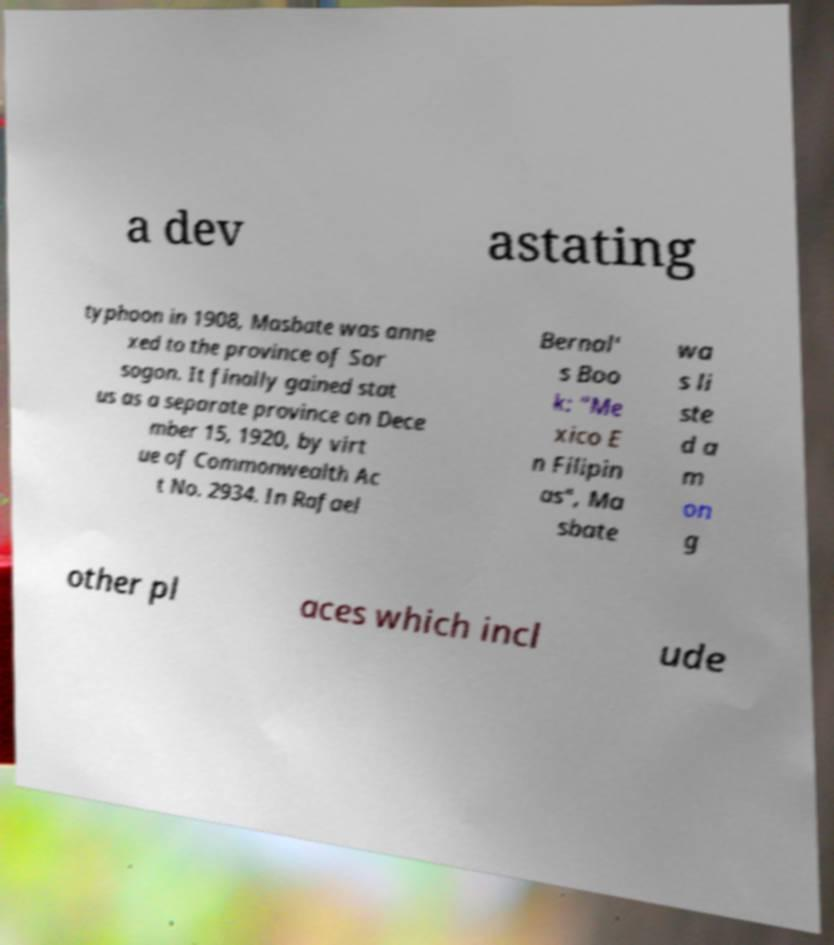Could you extract and type out the text from this image? a dev astating typhoon in 1908, Masbate was anne xed to the province of Sor sogon. It finally gained stat us as a separate province on Dece mber 15, 1920, by virt ue of Commonwealth Ac t No. 2934. In Rafael Bernal' s Boo k: "Me xico E n Filipin as", Ma sbate wa s li ste d a m on g other pl aces which incl ude 